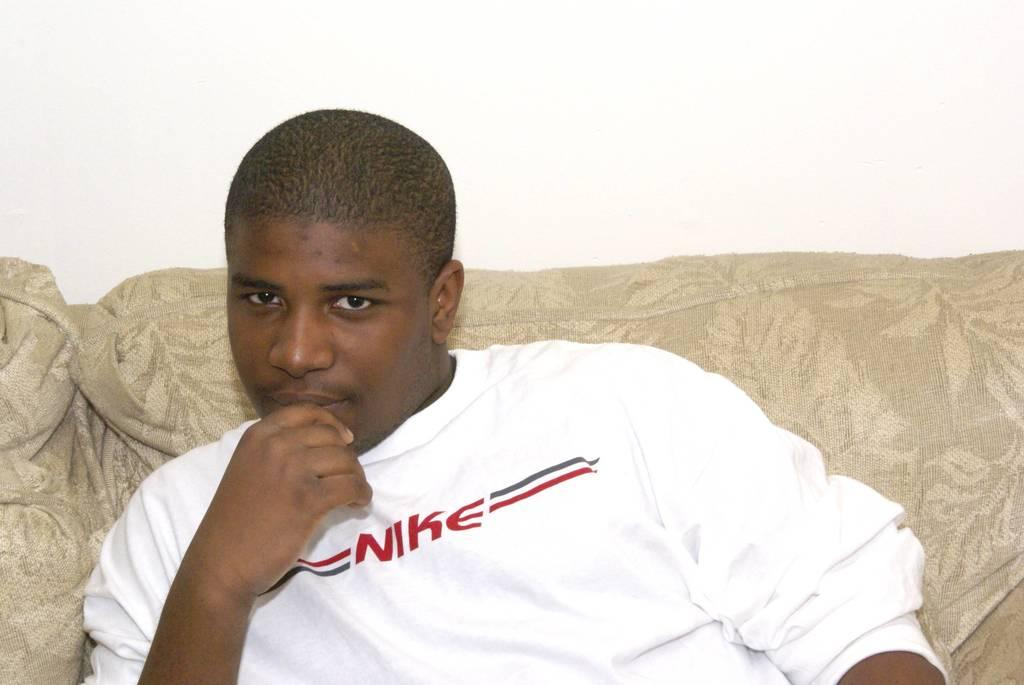<image>
Give a short and clear explanation of the subsequent image. A man sits on a couch in a white Nike sweater. 